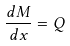Convert formula to latex. <formula><loc_0><loc_0><loc_500><loc_500>\frac { d M } { d x } = Q</formula> 